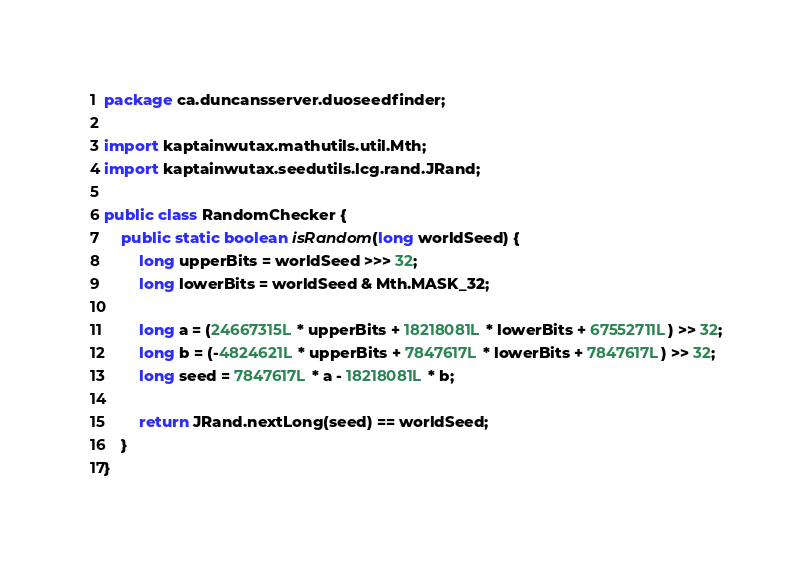<code> <loc_0><loc_0><loc_500><loc_500><_Java_>package ca.duncansserver.duoseedfinder;

import kaptainwutax.mathutils.util.Mth;
import kaptainwutax.seedutils.lcg.rand.JRand;

public class RandomChecker {
    public static boolean isRandom(long worldSeed) {
        long upperBits = worldSeed >>> 32;
        long lowerBits = worldSeed & Mth.MASK_32;

        long a = (24667315L * upperBits + 18218081L * lowerBits + 67552711L) >> 32;
        long b = (-4824621L * upperBits + 7847617L * lowerBits + 7847617L) >> 32;
        long seed = 7847617L * a - 18218081L * b;

        return JRand.nextLong(seed) == worldSeed;
    }
}
</code> 